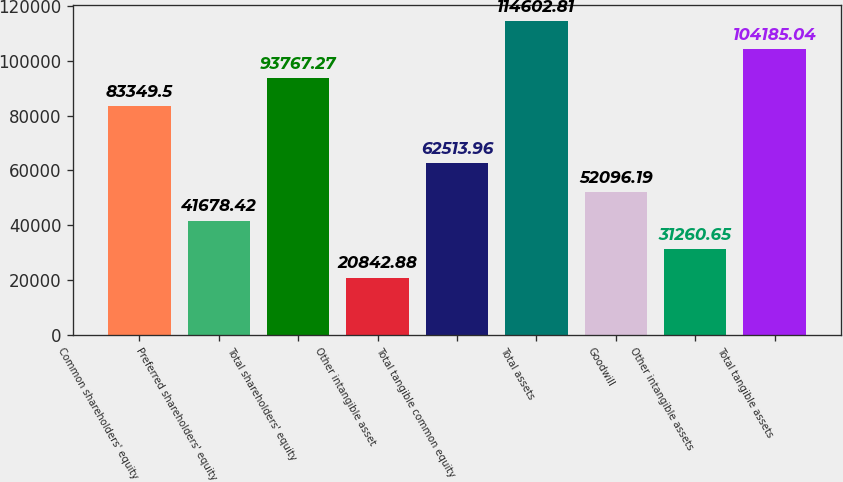Convert chart. <chart><loc_0><loc_0><loc_500><loc_500><bar_chart><fcel>Common shareholders' equity<fcel>Preferred shareholders' equity<fcel>Total shareholders' equity<fcel>Other intangible asset<fcel>Total tangible common equity<fcel>Total assets<fcel>Goodwill<fcel>Other intangible assets<fcel>Total tangible assets<nl><fcel>83349.5<fcel>41678.4<fcel>93767.3<fcel>20842.9<fcel>62514<fcel>114603<fcel>52096.2<fcel>31260.7<fcel>104185<nl></chart> 